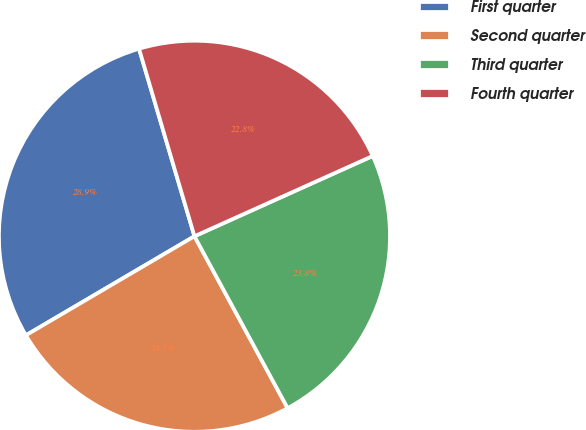Convert chart to OTSL. <chart><loc_0><loc_0><loc_500><loc_500><pie_chart><fcel>First quarter<fcel>Second quarter<fcel>Third quarter<fcel>Fourth quarter<nl><fcel>28.88%<fcel>24.45%<fcel>23.83%<fcel>22.84%<nl></chart> 